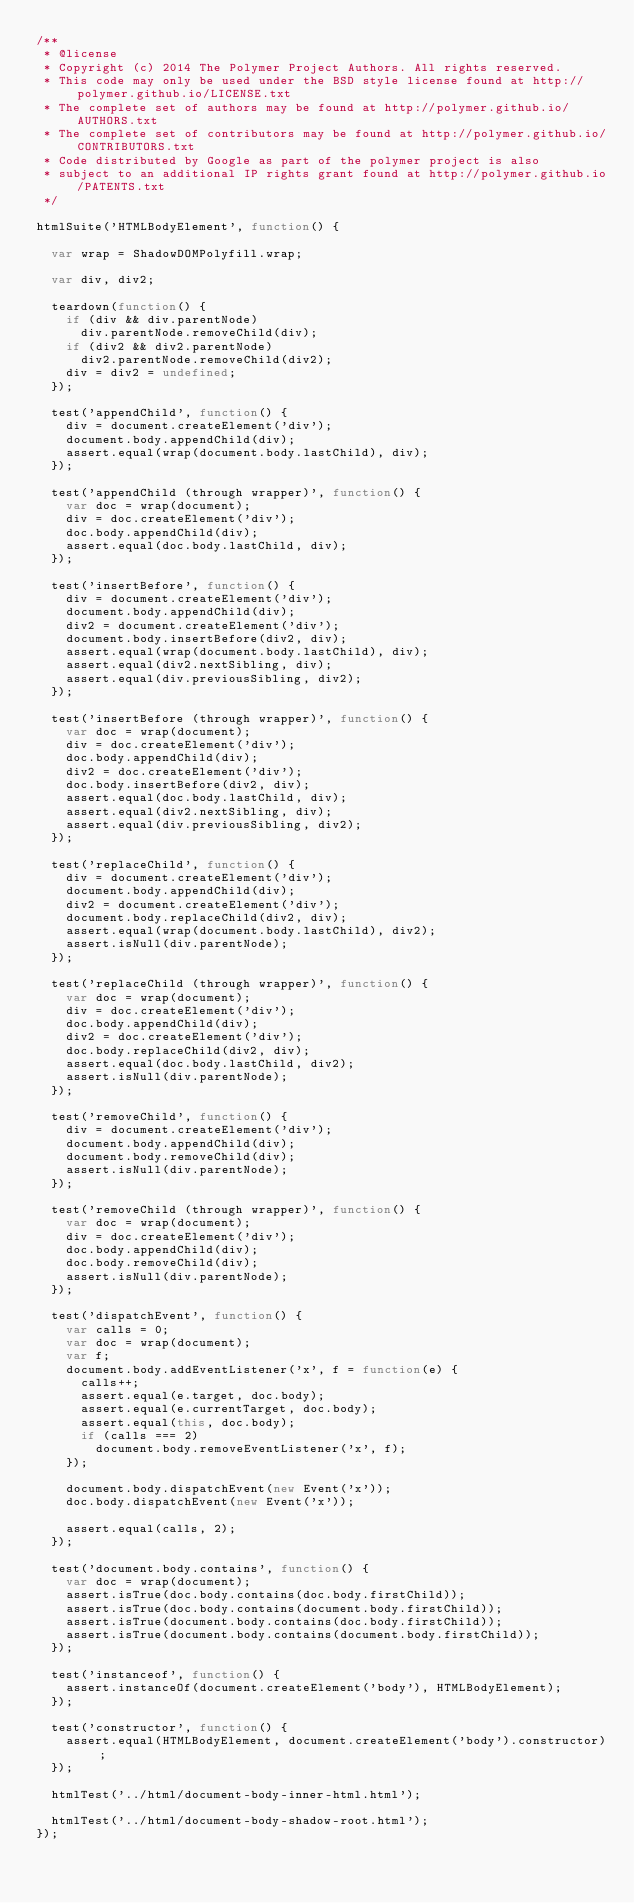Convert code to text. <code><loc_0><loc_0><loc_500><loc_500><_JavaScript_>/**
 * @license
 * Copyright (c) 2014 The Polymer Project Authors. All rights reserved.
 * This code may only be used under the BSD style license found at http://polymer.github.io/LICENSE.txt
 * The complete set of authors may be found at http://polymer.github.io/AUTHORS.txt
 * The complete set of contributors may be found at http://polymer.github.io/CONTRIBUTORS.txt
 * Code distributed by Google as part of the polymer project is also
 * subject to an additional IP rights grant found at http://polymer.github.io/PATENTS.txt
 */

htmlSuite('HTMLBodyElement', function() {

  var wrap = ShadowDOMPolyfill.wrap;

  var div, div2;

  teardown(function() {
    if (div && div.parentNode)
      div.parentNode.removeChild(div);
    if (div2 && div2.parentNode)
      div2.parentNode.removeChild(div2);
    div = div2 = undefined;
  });

  test('appendChild', function() {
    div = document.createElement('div');
    document.body.appendChild(div);
    assert.equal(wrap(document.body.lastChild), div);
  });

  test('appendChild (through wrapper)', function() {
    var doc = wrap(document);
    div = doc.createElement('div');
    doc.body.appendChild(div);
    assert.equal(doc.body.lastChild, div);
  });

  test('insertBefore', function() {
    div = document.createElement('div');
    document.body.appendChild(div);
    div2 = document.createElement('div');
    document.body.insertBefore(div2, div);
    assert.equal(wrap(document.body.lastChild), div);
    assert.equal(div2.nextSibling, div);
    assert.equal(div.previousSibling, div2);
  });

  test('insertBefore (through wrapper)', function() {
    var doc = wrap(document);
    div = doc.createElement('div');
    doc.body.appendChild(div);
    div2 = doc.createElement('div');
    doc.body.insertBefore(div2, div);
    assert.equal(doc.body.lastChild, div);
    assert.equal(div2.nextSibling, div);
    assert.equal(div.previousSibling, div2);
  });

  test('replaceChild', function() {
    div = document.createElement('div');
    document.body.appendChild(div);
    div2 = document.createElement('div');
    document.body.replaceChild(div2, div);
    assert.equal(wrap(document.body.lastChild), div2);
    assert.isNull(div.parentNode);
  });

  test('replaceChild (through wrapper)', function() {
    var doc = wrap(document);
    div = doc.createElement('div');
    doc.body.appendChild(div);
    div2 = doc.createElement('div');
    doc.body.replaceChild(div2, div);
    assert.equal(doc.body.lastChild, div2);
    assert.isNull(div.parentNode);
  });

  test('removeChild', function() {
    div = document.createElement('div');
    document.body.appendChild(div);
    document.body.removeChild(div);
    assert.isNull(div.parentNode);
  });

  test('removeChild (through wrapper)', function() {
    var doc = wrap(document);
    div = doc.createElement('div');
    doc.body.appendChild(div);
    doc.body.removeChild(div);
    assert.isNull(div.parentNode);
  });

  test('dispatchEvent', function() {
    var calls = 0;
    var doc = wrap(document);
    var f;
    document.body.addEventListener('x', f = function(e) {
      calls++;
      assert.equal(e.target, doc.body);
      assert.equal(e.currentTarget, doc.body);
      assert.equal(this, doc.body);
      if (calls === 2)
        document.body.removeEventListener('x', f);
    });

    document.body.dispatchEvent(new Event('x'));
    doc.body.dispatchEvent(new Event('x'));

    assert.equal(calls, 2);
  });

  test('document.body.contains', function() {
    var doc = wrap(document);
    assert.isTrue(doc.body.contains(doc.body.firstChild));
    assert.isTrue(doc.body.contains(document.body.firstChild));
    assert.isTrue(document.body.contains(doc.body.firstChild));
    assert.isTrue(document.body.contains(document.body.firstChild));
  });

  test('instanceof', function() {
    assert.instanceOf(document.createElement('body'), HTMLBodyElement);
  });

  test('constructor', function() {
    assert.equal(HTMLBodyElement, document.createElement('body').constructor);
  });

  htmlTest('../html/document-body-inner-html.html');

  htmlTest('../html/document-body-shadow-root.html');
});
</code> 